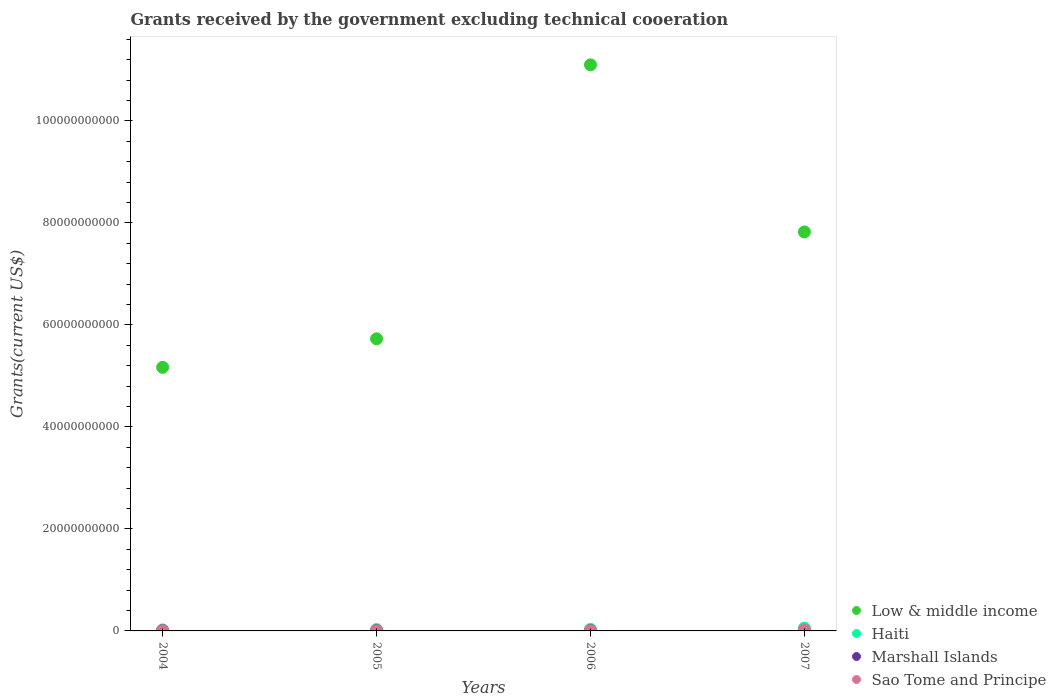What is the total grants received by the government in Sao Tome and Principe in 2006?
Give a very brief answer. 1.94e+07. Across all years, what is the maximum total grants received by the government in Marshall Islands?
Provide a succinct answer. 5.19e+07. Across all years, what is the minimum total grants received by the government in Marshall Islands?
Your answer should be compact. 4.58e+07. In which year was the total grants received by the government in Marshall Islands minimum?
Provide a short and direct response. 2004. What is the total total grants received by the government in Marshall Islands in the graph?
Your response must be concise. 2.00e+08. What is the difference between the total grants received by the government in Sao Tome and Principe in 2005 and that in 2006?
Your answer should be very brief. 2.39e+06. What is the difference between the total grants received by the government in Marshall Islands in 2006 and the total grants received by the government in Low & middle income in 2005?
Give a very brief answer. -5.72e+1. What is the average total grants received by the government in Sao Tome and Principe per year?
Ensure brevity in your answer.  7.11e+07. In the year 2007, what is the difference between the total grants received by the government in Haiti and total grants received by the government in Sao Tome and Principe?
Keep it short and to the point. 3.24e+08. In how many years, is the total grants received by the government in Low & middle income greater than 72000000000 US$?
Give a very brief answer. 2. What is the ratio of the total grants received by the government in Sao Tome and Principe in 2005 to that in 2007?
Your response must be concise. 0.1. Is the difference between the total grants received by the government in Haiti in 2004 and 2006 greater than the difference between the total grants received by the government in Sao Tome and Principe in 2004 and 2006?
Keep it short and to the point. No. What is the difference between the highest and the second highest total grants received by the government in Sao Tome and Principe?
Offer a very short reply. 2.01e+08. What is the difference between the highest and the lowest total grants received by the government in Low & middle income?
Your answer should be very brief. 5.93e+1. Is the sum of the total grants received by the government in Haiti in 2006 and 2007 greater than the maximum total grants received by the government in Sao Tome and Principe across all years?
Your answer should be compact. Yes. Is it the case that in every year, the sum of the total grants received by the government in Sao Tome and Principe and total grants received by the government in Haiti  is greater than the total grants received by the government in Marshall Islands?
Offer a terse response. Yes. Does the total grants received by the government in Haiti monotonically increase over the years?
Provide a short and direct response. Yes. Is the total grants received by the government in Sao Tome and Principe strictly less than the total grants received by the government in Marshall Islands over the years?
Give a very brief answer. No. How many dotlines are there?
Provide a succinct answer. 4. How many years are there in the graph?
Provide a succinct answer. 4. What is the difference between two consecutive major ticks on the Y-axis?
Your answer should be compact. 2.00e+1. Does the graph contain any zero values?
Offer a terse response. No. How many legend labels are there?
Provide a short and direct response. 4. What is the title of the graph?
Offer a very short reply. Grants received by the government excluding technical cooeration. What is the label or title of the X-axis?
Offer a very short reply. Years. What is the label or title of the Y-axis?
Your answer should be compact. Grants(current US$). What is the Grants(current US$) of Low & middle income in 2004?
Make the answer very short. 5.17e+1. What is the Grants(current US$) of Haiti in 2004?
Give a very brief answer. 2.04e+08. What is the Grants(current US$) of Marshall Islands in 2004?
Offer a very short reply. 4.58e+07. What is the Grants(current US$) in Sao Tome and Principe in 2004?
Give a very brief answer. 1.99e+07. What is the Grants(current US$) in Low & middle income in 2005?
Make the answer very short. 5.73e+1. What is the Grants(current US$) in Haiti in 2005?
Give a very brief answer. 2.71e+08. What is the Grants(current US$) in Marshall Islands in 2005?
Provide a succinct answer. 5.19e+07. What is the Grants(current US$) of Sao Tome and Principe in 2005?
Ensure brevity in your answer.  2.17e+07. What is the Grants(current US$) of Low & middle income in 2006?
Offer a terse response. 1.11e+11. What is the Grants(current US$) of Haiti in 2006?
Your response must be concise. 3.05e+08. What is the Grants(current US$) of Marshall Islands in 2006?
Your answer should be very brief. 5.19e+07. What is the Grants(current US$) in Sao Tome and Principe in 2006?
Keep it short and to the point. 1.94e+07. What is the Grants(current US$) in Low & middle income in 2007?
Your response must be concise. 7.82e+1. What is the Grants(current US$) in Haiti in 2007?
Give a very brief answer. 5.47e+08. What is the Grants(current US$) in Marshall Islands in 2007?
Give a very brief answer. 5.00e+07. What is the Grants(current US$) of Sao Tome and Principe in 2007?
Provide a short and direct response. 2.23e+08. Across all years, what is the maximum Grants(current US$) of Low & middle income?
Provide a succinct answer. 1.11e+11. Across all years, what is the maximum Grants(current US$) in Haiti?
Give a very brief answer. 5.47e+08. Across all years, what is the maximum Grants(current US$) in Marshall Islands?
Provide a short and direct response. 5.19e+07. Across all years, what is the maximum Grants(current US$) in Sao Tome and Principe?
Offer a very short reply. 2.23e+08. Across all years, what is the minimum Grants(current US$) in Low & middle income?
Provide a short and direct response. 5.17e+1. Across all years, what is the minimum Grants(current US$) in Haiti?
Provide a short and direct response. 2.04e+08. Across all years, what is the minimum Grants(current US$) of Marshall Islands?
Give a very brief answer. 4.58e+07. Across all years, what is the minimum Grants(current US$) of Sao Tome and Principe?
Your response must be concise. 1.94e+07. What is the total Grants(current US$) in Low & middle income in the graph?
Your answer should be compact. 2.98e+11. What is the total Grants(current US$) in Haiti in the graph?
Offer a terse response. 1.33e+09. What is the total Grants(current US$) of Marshall Islands in the graph?
Provide a short and direct response. 2.00e+08. What is the total Grants(current US$) in Sao Tome and Principe in the graph?
Keep it short and to the point. 2.84e+08. What is the difference between the Grants(current US$) of Low & middle income in 2004 and that in 2005?
Your answer should be very brief. -5.59e+09. What is the difference between the Grants(current US$) of Haiti in 2004 and that in 2005?
Give a very brief answer. -6.68e+07. What is the difference between the Grants(current US$) of Marshall Islands in 2004 and that in 2005?
Your answer should be compact. -6.11e+06. What is the difference between the Grants(current US$) of Sao Tome and Principe in 2004 and that in 2005?
Your answer should be very brief. -1.82e+06. What is the difference between the Grants(current US$) of Low & middle income in 2004 and that in 2006?
Ensure brevity in your answer.  -5.93e+1. What is the difference between the Grants(current US$) in Haiti in 2004 and that in 2006?
Make the answer very short. -1.02e+08. What is the difference between the Grants(current US$) in Marshall Islands in 2004 and that in 2006?
Keep it short and to the point. -6.08e+06. What is the difference between the Grants(current US$) in Sao Tome and Principe in 2004 and that in 2006?
Make the answer very short. 5.70e+05. What is the difference between the Grants(current US$) in Low & middle income in 2004 and that in 2007?
Offer a very short reply. -2.65e+1. What is the difference between the Grants(current US$) in Haiti in 2004 and that in 2007?
Your answer should be compact. -3.43e+08. What is the difference between the Grants(current US$) in Marshall Islands in 2004 and that in 2007?
Offer a terse response. -4.18e+06. What is the difference between the Grants(current US$) in Sao Tome and Principe in 2004 and that in 2007?
Ensure brevity in your answer.  -2.03e+08. What is the difference between the Grants(current US$) in Low & middle income in 2005 and that in 2006?
Your response must be concise. -5.37e+1. What is the difference between the Grants(current US$) in Haiti in 2005 and that in 2006?
Your answer should be compact. -3.48e+07. What is the difference between the Grants(current US$) of Marshall Islands in 2005 and that in 2006?
Your answer should be very brief. 3.00e+04. What is the difference between the Grants(current US$) of Sao Tome and Principe in 2005 and that in 2006?
Offer a very short reply. 2.39e+06. What is the difference between the Grants(current US$) of Low & middle income in 2005 and that in 2007?
Your answer should be very brief. -2.10e+1. What is the difference between the Grants(current US$) of Haiti in 2005 and that in 2007?
Your answer should be very brief. -2.77e+08. What is the difference between the Grants(current US$) in Marshall Islands in 2005 and that in 2007?
Your answer should be compact. 1.93e+06. What is the difference between the Grants(current US$) in Sao Tome and Principe in 2005 and that in 2007?
Offer a very short reply. -2.01e+08. What is the difference between the Grants(current US$) in Low & middle income in 2006 and that in 2007?
Offer a terse response. 3.28e+1. What is the difference between the Grants(current US$) of Haiti in 2006 and that in 2007?
Your answer should be very brief. -2.42e+08. What is the difference between the Grants(current US$) of Marshall Islands in 2006 and that in 2007?
Keep it short and to the point. 1.90e+06. What is the difference between the Grants(current US$) in Sao Tome and Principe in 2006 and that in 2007?
Your answer should be very brief. -2.04e+08. What is the difference between the Grants(current US$) in Low & middle income in 2004 and the Grants(current US$) in Haiti in 2005?
Your response must be concise. 5.14e+1. What is the difference between the Grants(current US$) in Low & middle income in 2004 and the Grants(current US$) in Marshall Islands in 2005?
Your answer should be very brief. 5.16e+1. What is the difference between the Grants(current US$) in Low & middle income in 2004 and the Grants(current US$) in Sao Tome and Principe in 2005?
Give a very brief answer. 5.17e+1. What is the difference between the Grants(current US$) of Haiti in 2004 and the Grants(current US$) of Marshall Islands in 2005?
Ensure brevity in your answer.  1.52e+08. What is the difference between the Grants(current US$) of Haiti in 2004 and the Grants(current US$) of Sao Tome and Principe in 2005?
Your answer should be very brief. 1.82e+08. What is the difference between the Grants(current US$) of Marshall Islands in 2004 and the Grants(current US$) of Sao Tome and Principe in 2005?
Your answer should be compact. 2.41e+07. What is the difference between the Grants(current US$) of Low & middle income in 2004 and the Grants(current US$) of Haiti in 2006?
Your answer should be very brief. 5.14e+1. What is the difference between the Grants(current US$) in Low & middle income in 2004 and the Grants(current US$) in Marshall Islands in 2006?
Provide a succinct answer. 5.16e+1. What is the difference between the Grants(current US$) in Low & middle income in 2004 and the Grants(current US$) in Sao Tome and Principe in 2006?
Offer a very short reply. 5.17e+1. What is the difference between the Grants(current US$) of Haiti in 2004 and the Grants(current US$) of Marshall Islands in 2006?
Offer a terse response. 1.52e+08. What is the difference between the Grants(current US$) of Haiti in 2004 and the Grants(current US$) of Sao Tome and Principe in 2006?
Give a very brief answer. 1.84e+08. What is the difference between the Grants(current US$) of Marshall Islands in 2004 and the Grants(current US$) of Sao Tome and Principe in 2006?
Your answer should be compact. 2.64e+07. What is the difference between the Grants(current US$) of Low & middle income in 2004 and the Grants(current US$) of Haiti in 2007?
Offer a very short reply. 5.11e+1. What is the difference between the Grants(current US$) in Low & middle income in 2004 and the Grants(current US$) in Marshall Islands in 2007?
Your answer should be very brief. 5.16e+1. What is the difference between the Grants(current US$) of Low & middle income in 2004 and the Grants(current US$) of Sao Tome and Principe in 2007?
Your answer should be very brief. 5.15e+1. What is the difference between the Grants(current US$) of Haiti in 2004 and the Grants(current US$) of Marshall Islands in 2007?
Your answer should be compact. 1.54e+08. What is the difference between the Grants(current US$) in Haiti in 2004 and the Grants(current US$) in Sao Tome and Principe in 2007?
Your response must be concise. -1.94e+07. What is the difference between the Grants(current US$) in Marshall Islands in 2004 and the Grants(current US$) in Sao Tome and Principe in 2007?
Make the answer very short. -1.77e+08. What is the difference between the Grants(current US$) of Low & middle income in 2005 and the Grants(current US$) of Haiti in 2006?
Your answer should be compact. 5.70e+1. What is the difference between the Grants(current US$) of Low & middle income in 2005 and the Grants(current US$) of Marshall Islands in 2006?
Offer a very short reply. 5.72e+1. What is the difference between the Grants(current US$) in Low & middle income in 2005 and the Grants(current US$) in Sao Tome and Principe in 2006?
Keep it short and to the point. 5.72e+1. What is the difference between the Grants(current US$) of Haiti in 2005 and the Grants(current US$) of Marshall Islands in 2006?
Keep it short and to the point. 2.19e+08. What is the difference between the Grants(current US$) in Haiti in 2005 and the Grants(current US$) in Sao Tome and Principe in 2006?
Offer a very short reply. 2.51e+08. What is the difference between the Grants(current US$) of Marshall Islands in 2005 and the Grants(current US$) of Sao Tome and Principe in 2006?
Provide a short and direct response. 3.26e+07. What is the difference between the Grants(current US$) in Low & middle income in 2005 and the Grants(current US$) in Haiti in 2007?
Ensure brevity in your answer.  5.67e+1. What is the difference between the Grants(current US$) of Low & middle income in 2005 and the Grants(current US$) of Marshall Islands in 2007?
Your answer should be compact. 5.72e+1. What is the difference between the Grants(current US$) in Low & middle income in 2005 and the Grants(current US$) in Sao Tome and Principe in 2007?
Your response must be concise. 5.70e+1. What is the difference between the Grants(current US$) in Haiti in 2005 and the Grants(current US$) in Marshall Islands in 2007?
Ensure brevity in your answer.  2.21e+08. What is the difference between the Grants(current US$) in Haiti in 2005 and the Grants(current US$) in Sao Tome and Principe in 2007?
Your answer should be compact. 4.74e+07. What is the difference between the Grants(current US$) of Marshall Islands in 2005 and the Grants(current US$) of Sao Tome and Principe in 2007?
Make the answer very short. -1.71e+08. What is the difference between the Grants(current US$) in Low & middle income in 2006 and the Grants(current US$) in Haiti in 2007?
Your answer should be very brief. 1.10e+11. What is the difference between the Grants(current US$) of Low & middle income in 2006 and the Grants(current US$) of Marshall Islands in 2007?
Offer a very short reply. 1.11e+11. What is the difference between the Grants(current US$) in Low & middle income in 2006 and the Grants(current US$) in Sao Tome and Principe in 2007?
Offer a terse response. 1.11e+11. What is the difference between the Grants(current US$) in Haiti in 2006 and the Grants(current US$) in Marshall Islands in 2007?
Your answer should be very brief. 2.55e+08. What is the difference between the Grants(current US$) in Haiti in 2006 and the Grants(current US$) in Sao Tome and Principe in 2007?
Your answer should be very brief. 8.22e+07. What is the difference between the Grants(current US$) in Marshall Islands in 2006 and the Grants(current US$) in Sao Tome and Principe in 2007?
Ensure brevity in your answer.  -1.71e+08. What is the average Grants(current US$) of Low & middle income per year?
Offer a terse response. 7.45e+1. What is the average Grants(current US$) of Haiti per year?
Make the answer very short. 3.32e+08. What is the average Grants(current US$) in Marshall Islands per year?
Ensure brevity in your answer.  4.99e+07. What is the average Grants(current US$) of Sao Tome and Principe per year?
Provide a short and direct response. 7.11e+07. In the year 2004, what is the difference between the Grants(current US$) in Low & middle income and Grants(current US$) in Haiti?
Make the answer very short. 5.15e+1. In the year 2004, what is the difference between the Grants(current US$) in Low & middle income and Grants(current US$) in Marshall Islands?
Your answer should be compact. 5.16e+1. In the year 2004, what is the difference between the Grants(current US$) of Low & middle income and Grants(current US$) of Sao Tome and Principe?
Offer a terse response. 5.17e+1. In the year 2004, what is the difference between the Grants(current US$) of Haiti and Grants(current US$) of Marshall Islands?
Ensure brevity in your answer.  1.58e+08. In the year 2004, what is the difference between the Grants(current US$) of Haiti and Grants(current US$) of Sao Tome and Principe?
Give a very brief answer. 1.84e+08. In the year 2004, what is the difference between the Grants(current US$) in Marshall Islands and Grants(current US$) in Sao Tome and Principe?
Ensure brevity in your answer.  2.59e+07. In the year 2005, what is the difference between the Grants(current US$) in Low & middle income and Grants(current US$) in Haiti?
Ensure brevity in your answer.  5.70e+1. In the year 2005, what is the difference between the Grants(current US$) in Low & middle income and Grants(current US$) in Marshall Islands?
Give a very brief answer. 5.72e+1. In the year 2005, what is the difference between the Grants(current US$) of Low & middle income and Grants(current US$) of Sao Tome and Principe?
Give a very brief answer. 5.72e+1. In the year 2005, what is the difference between the Grants(current US$) in Haiti and Grants(current US$) in Marshall Islands?
Your answer should be compact. 2.19e+08. In the year 2005, what is the difference between the Grants(current US$) in Haiti and Grants(current US$) in Sao Tome and Principe?
Provide a succinct answer. 2.49e+08. In the year 2005, what is the difference between the Grants(current US$) of Marshall Islands and Grants(current US$) of Sao Tome and Principe?
Offer a terse response. 3.02e+07. In the year 2006, what is the difference between the Grants(current US$) of Low & middle income and Grants(current US$) of Haiti?
Make the answer very short. 1.11e+11. In the year 2006, what is the difference between the Grants(current US$) of Low & middle income and Grants(current US$) of Marshall Islands?
Offer a terse response. 1.11e+11. In the year 2006, what is the difference between the Grants(current US$) in Low & middle income and Grants(current US$) in Sao Tome and Principe?
Your response must be concise. 1.11e+11. In the year 2006, what is the difference between the Grants(current US$) of Haiti and Grants(current US$) of Marshall Islands?
Provide a short and direct response. 2.54e+08. In the year 2006, what is the difference between the Grants(current US$) of Haiti and Grants(current US$) of Sao Tome and Principe?
Keep it short and to the point. 2.86e+08. In the year 2006, what is the difference between the Grants(current US$) of Marshall Islands and Grants(current US$) of Sao Tome and Principe?
Your response must be concise. 3.25e+07. In the year 2007, what is the difference between the Grants(current US$) of Low & middle income and Grants(current US$) of Haiti?
Ensure brevity in your answer.  7.77e+1. In the year 2007, what is the difference between the Grants(current US$) in Low & middle income and Grants(current US$) in Marshall Islands?
Provide a succinct answer. 7.82e+1. In the year 2007, what is the difference between the Grants(current US$) of Low & middle income and Grants(current US$) of Sao Tome and Principe?
Provide a succinct answer. 7.80e+1. In the year 2007, what is the difference between the Grants(current US$) of Haiti and Grants(current US$) of Marshall Islands?
Your answer should be compact. 4.97e+08. In the year 2007, what is the difference between the Grants(current US$) of Haiti and Grants(current US$) of Sao Tome and Principe?
Make the answer very short. 3.24e+08. In the year 2007, what is the difference between the Grants(current US$) of Marshall Islands and Grants(current US$) of Sao Tome and Principe?
Your answer should be very brief. -1.73e+08. What is the ratio of the Grants(current US$) in Low & middle income in 2004 to that in 2005?
Give a very brief answer. 0.9. What is the ratio of the Grants(current US$) of Haiti in 2004 to that in 2005?
Offer a very short reply. 0.75. What is the ratio of the Grants(current US$) of Marshall Islands in 2004 to that in 2005?
Ensure brevity in your answer.  0.88. What is the ratio of the Grants(current US$) in Sao Tome and Principe in 2004 to that in 2005?
Your answer should be very brief. 0.92. What is the ratio of the Grants(current US$) in Low & middle income in 2004 to that in 2006?
Make the answer very short. 0.47. What is the ratio of the Grants(current US$) of Haiti in 2004 to that in 2006?
Ensure brevity in your answer.  0.67. What is the ratio of the Grants(current US$) of Marshall Islands in 2004 to that in 2006?
Your answer should be very brief. 0.88. What is the ratio of the Grants(current US$) in Sao Tome and Principe in 2004 to that in 2006?
Provide a succinct answer. 1.03. What is the ratio of the Grants(current US$) of Low & middle income in 2004 to that in 2007?
Offer a terse response. 0.66. What is the ratio of the Grants(current US$) of Haiti in 2004 to that in 2007?
Ensure brevity in your answer.  0.37. What is the ratio of the Grants(current US$) in Marshall Islands in 2004 to that in 2007?
Ensure brevity in your answer.  0.92. What is the ratio of the Grants(current US$) in Sao Tome and Principe in 2004 to that in 2007?
Your response must be concise. 0.09. What is the ratio of the Grants(current US$) of Low & middle income in 2005 to that in 2006?
Keep it short and to the point. 0.52. What is the ratio of the Grants(current US$) in Haiti in 2005 to that in 2006?
Give a very brief answer. 0.89. What is the ratio of the Grants(current US$) in Sao Tome and Principe in 2005 to that in 2006?
Make the answer very short. 1.12. What is the ratio of the Grants(current US$) in Low & middle income in 2005 to that in 2007?
Provide a short and direct response. 0.73. What is the ratio of the Grants(current US$) of Haiti in 2005 to that in 2007?
Make the answer very short. 0.49. What is the ratio of the Grants(current US$) of Marshall Islands in 2005 to that in 2007?
Give a very brief answer. 1.04. What is the ratio of the Grants(current US$) of Sao Tome and Principe in 2005 to that in 2007?
Your answer should be compact. 0.1. What is the ratio of the Grants(current US$) in Low & middle income in 2006 to that in 2007?
Make the answer very short. 1.42. What is the ratio of the Grants(current US$) of Haiti in 2006 to that in 2007?
Provide a succinct answer. 0.56. What is the ratio of the Grants(current US$) in Marshall Islands in 2006 to that in 2007?
Ensure brevity in your answer.  1.04. What is the ratio of the Grants(current US$) of Sao Tome and Principe in 2006 to that in 2007?
Your response must be concise. 0.09. What is the difference between the highest and the second highest Grants(current US$) of Low & middle income?
Provide a short and direct response. 3.28e+1. What is the difference between the highest and the second highest Grants(current US$) of Haiti?
Keep it short and to the point. 2.42e+08. What is the difference between the highest and the second highest Grants(current US$) of Marshall Islands?
Offer a terse response. 3.00e+04. What is the difference between the highest and the second highest Grants(current US$) of Sao Tome and Principe?
Your response must be concise. 2.01e+08. What is the difference between the highest and the lowest Grants(current US$) in Low & middle income?
Ensure brevity in your answer.  5.93e+1. What is the difference between the highest and the lowest Grants(current US$) of Haiti?
Ensure brevity in your answer.  3.43e+08. What is the difference between the highest and the lowest Grants(current US$) in Marshall Islands?
Your answer should be very brief. 6.11e+06. What is the difference between the highest and the lowest Grants(current US$) of Sao Tome and Principe?
Keep it short and to the point. 2.04e+08. 